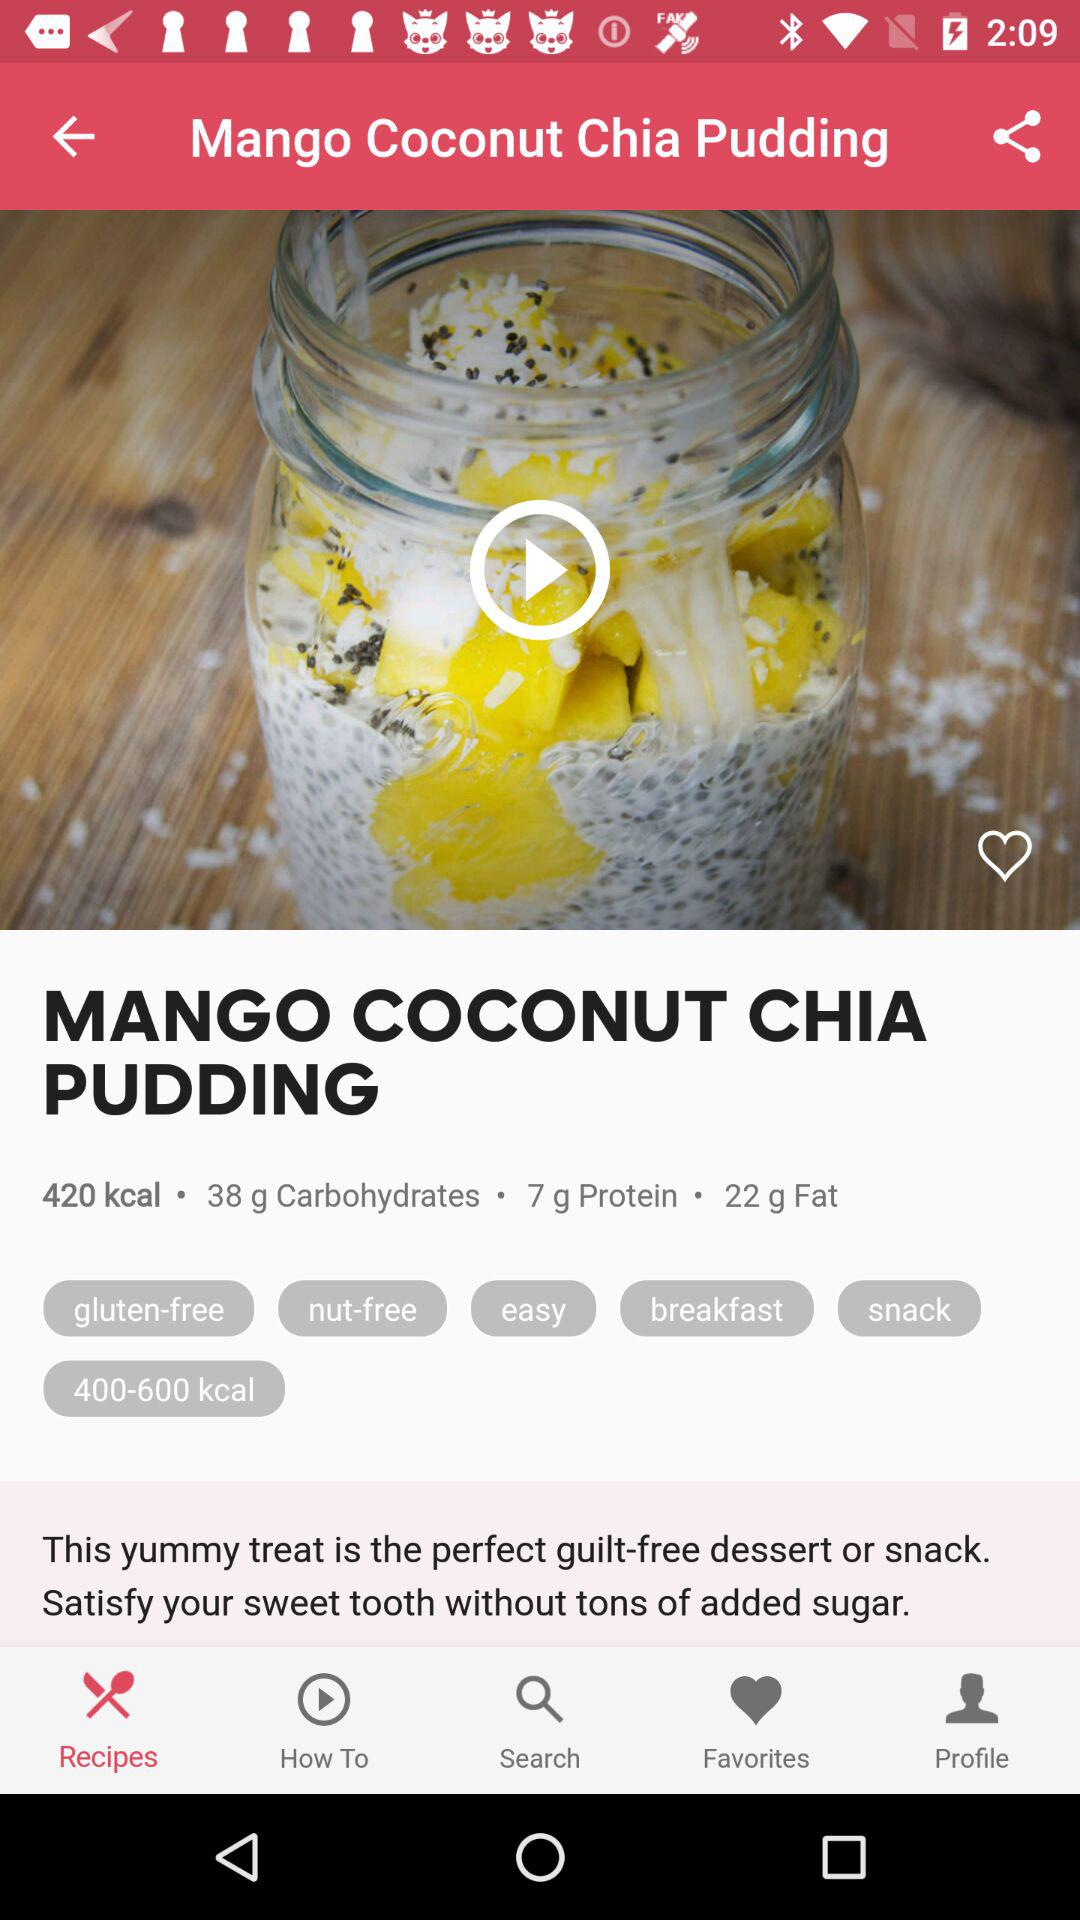How much protein is there? There is 7 gram protein. 